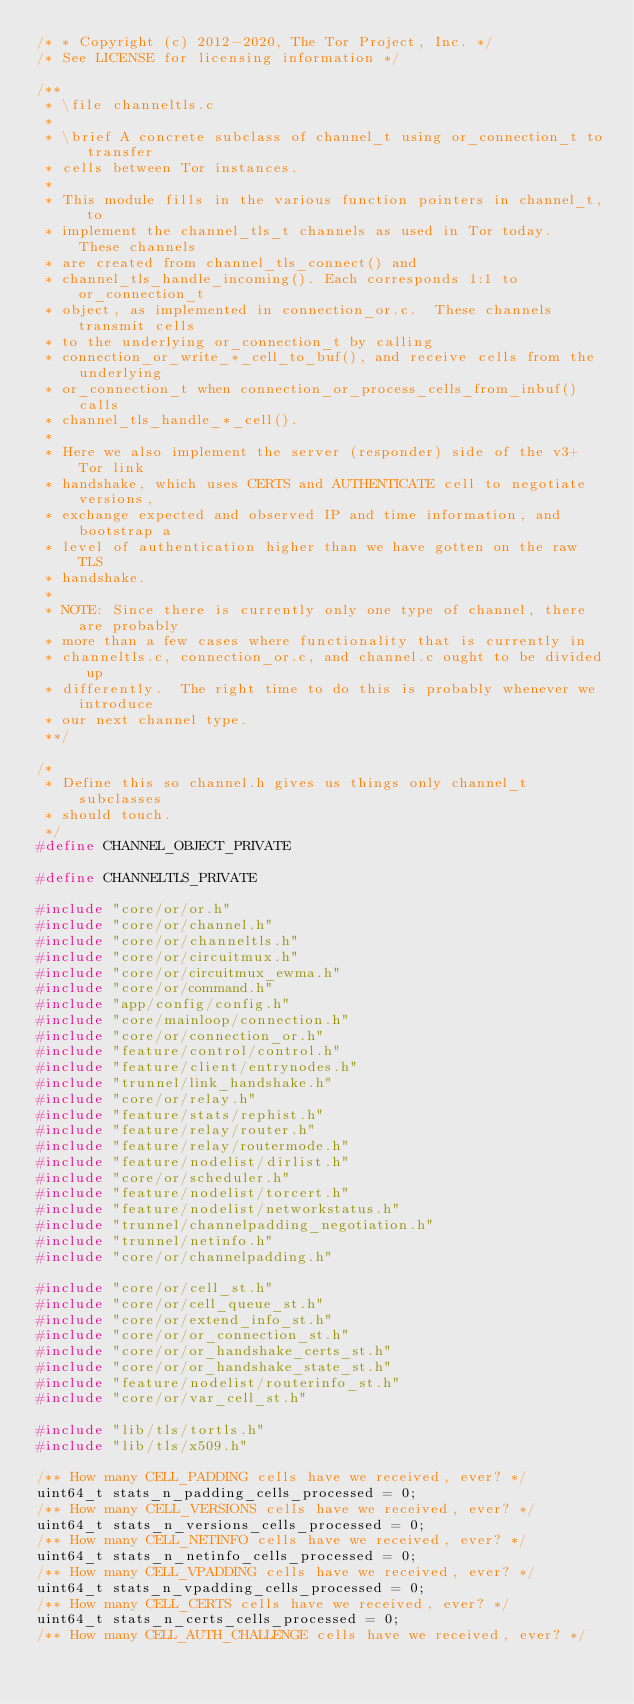Convert code to text. <code><loc_0><loc_0><loc_500><loc_500><_C_>/* * Copyright (c) 2012-2020, The Tor Project, Inc. */
/* See LICENSE for licensing information */

/**
 * \file channeltls.c
 *
 * \brief A concrete subclass of channel_t using or_connection_t to transfer
 * cells between Tor instances.
 *
 * This module fills in the various function pointers in channel_t, to
 * implement the channel_tls_t channels as used in Tor today.  These channels
 * are created from channel_tls_connect() and
 * channel_tls_handle_incoming(). Each corresponds 1:1 to or_connection_t
 * object, as implemented in connection_or.c.  These channels transmit cells
 * to the underlying or_connection_t by calling
 * connection_or_write_*_cell_to_buf(), and receive cells from the underlying
 * or_connection_t when connection_or_process_cells_from_inbuf() calls
 * channel_tls_handle_*_cell().
 *
 * Here we also implement the server (responder) side of the v3+ Tor link
 * handshake, which uses CERTS and AUTHENTICATE cell to negotiate versions,
 * exchange expected and observed IP and time information, and bootstrap a
 * level of authentication higher than we have gotten on the raw TLS
 * handshake.
 *
 * NOTE: Since there is currently only one type of channel, there are probably
 * more than a few cases where functionality that is currently in
 * channeltls.c, connection_or.c, and channel.c ought to be divided up
 * differently.  The right time to do this is probably whenever we introduce
 * our next channel type.
 **/

/*
 * Define this so channel.h gives us things only channel_t subclasses
 * should touch.
 */
#define CHANNEL_OBJECT_PRIVATE

#define CHANNELTLS_PRIVATE

#include "core/or/or.h"
#include "core/or/channel.h"
#include "core/or/channeltls.h"
#include "core/or/circuitmux.h"
#include "core/or/circuitmux_ewma.h"
#include "core/or/command.h"
#include "app/config/config.h"
#include "core/mainloop/connection.h"
#include "core/or/connection_or.h"
#include "feature/control/control.h"
#include "feature/client/entrynodes.h"
#include "trunnel/link_handshake.h"
#include "core/or/relay.h"
#include "feature/stats/rephist.h"
#include "feature/relay/router.h"
#include "feature/relay/routermode.h"
#include "feature/nodelist/dirlist.h"
#include "core/or/scheduler.h"
#include "feature/nodelist/torcert.h"
#include "feature/nodelist/networkstatus.h"
#include "trunnel/channelpadding_negotiation.h"
#include "trunnel/netinfo.h"
#include "core/or/channelpadding.h"

#include "core/or/cell_st.h"
#include "core/or/cell_queue_st.h"
#include "core/or/extend_info_st.h"
#include "core/or/or_connection_st.h"
#include "core/or/or_handshake_certs_st.h"
#include "core/or/or_handshake_state_st.h"
#include "feature/nodelist/routerinfo_st.h"
#include "core/or/var_cell_st.h"

#include "lib/tls/tortls.h"
#include "lib/tls/x509.h"

/** How many CELL_PADDING cells have we received, ever? */
uint64_t stats_n_padding_cells_processed = 0;
/** How many CELL_VERSIONS cells have we received, ever? */
uint64_t stats_n_versions_cells_processed = 0;
/** How many CELL_NETINFO cells have we received, ever? */
uint64_t stats_n_netinfo_cells_processed = 0;
/** How many CELL_VPADDING cells have we received, ever? */
uint64_t stats_n_vpadding_cells_processed = 0;
/** How many CELL_CERTS cells have we received, ever? */
uint64_t stats_n_certs_cells_processed = 0;
/** How many CELL_AUTH_CHALLENGE cells have we received, ever? */</code> 